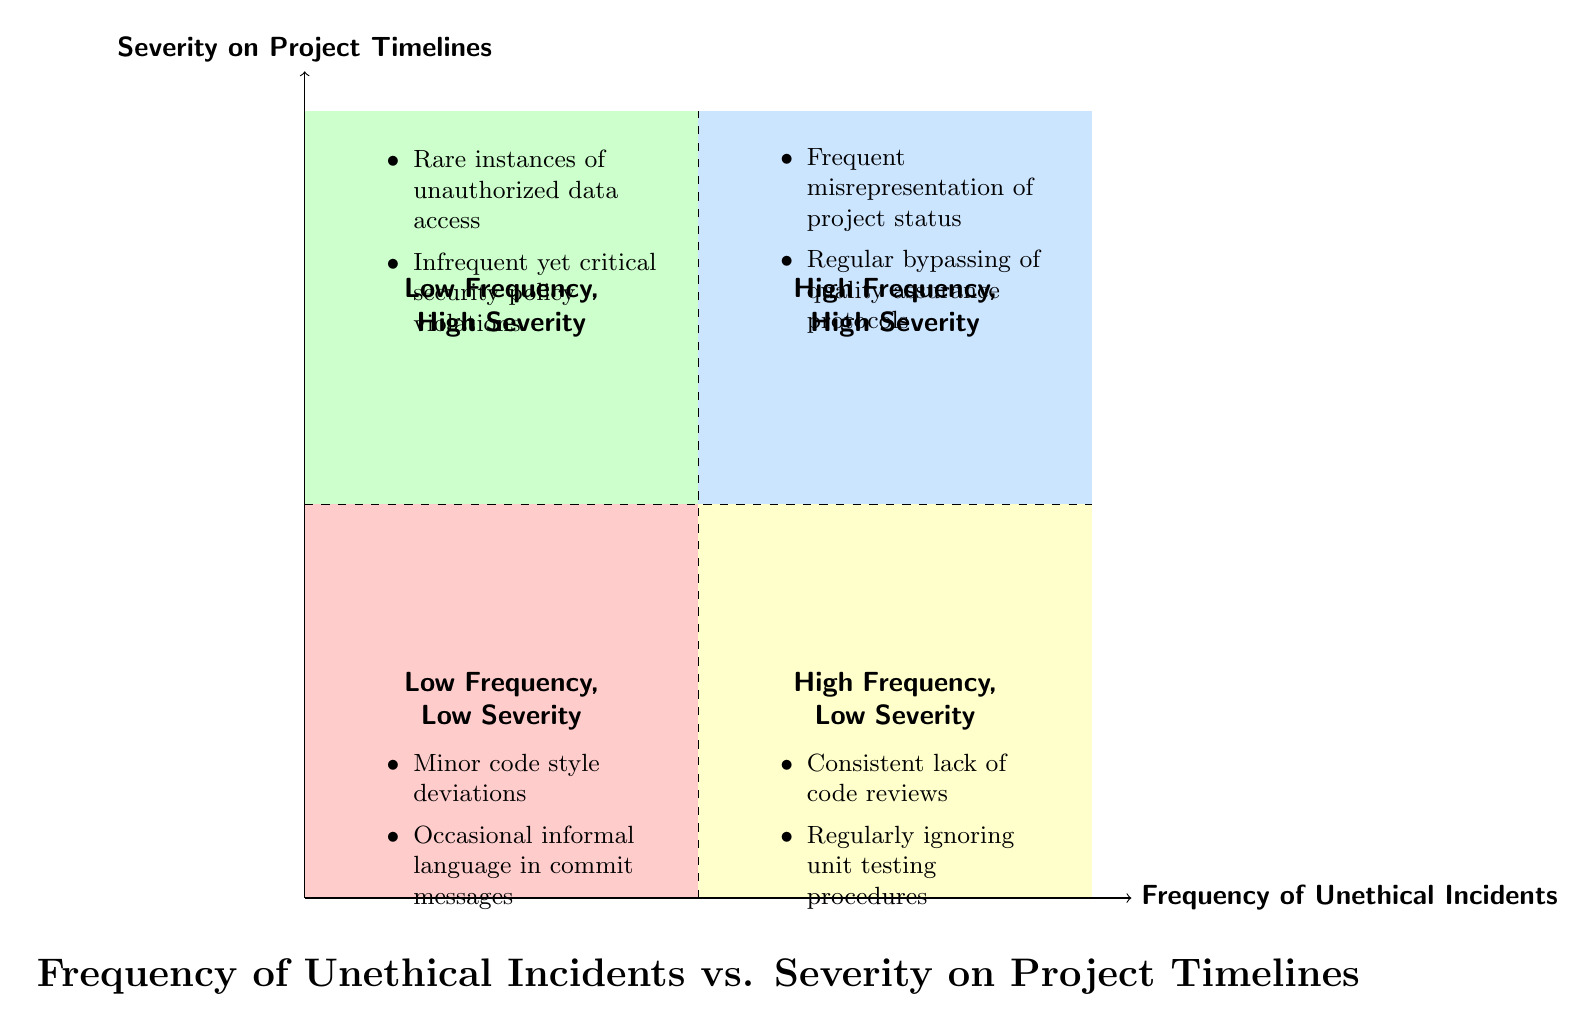What are the two labels for high frequency, high severity quadrant? The high frequency, high severity quadrant is labeled as "High Frequency, High Severity." The examples listed include "Frequent misrepresentation of project status" and "Regular bypassing of quality assurance protocols."
Answer: High Frequency, High Severity How many examples are listed in the low frequency, low severity quadrant? In the low frequency, low severity quadrant, there are two examples: "Minor code style deviations" and "Occasional informal language in commit messages." Therefore, the total count is 2.
Answer: 2 Which quadrant contains instances of unauthorized data access? Unauthorized data access is mentioned in the low frequency, high severity quadrant; thus, it is categorized there since it describes a rare but significant incident.
Answer: Low Frequency, High Severity What is the label of the quadrant with high frequency and low severity? The label for the quadrant with high frequency and low severity is "High Frequency, Low Severity," indicating that incidents here occur often but have less significant impact.
Answer: High Frequency, Low Severity Which type of incidents is represented in both high frequency and high severity? The quadrant for high frequency and high severity includes examples like "Frequent misrepresentation of project status" and "Regular bypassing of quality assurance protocols." This indicates the incidents pose serious risks while occurring frequently.
Answer: Frequent misrepresentation of project status, Regular bypassing of quality assurance protocols What kind of practices fall under the low frequency, high severity quadrant? The low frequency, high severity quadrant is characterized by significant incidents that occur rarely, such as "Rare instances of unauthorized data access" and "Infrequent yet critical security policy violations." This suggests that although these incidents are not common, they are critical when they do occur.
Answer: Rare instances of unauthorized data access, Infrequent yet critical security policy violations What is the primary characteristic of the high frequency, low severity incidents? Incidents categorized under high frequency and low severity typically exhibit a pattern of occurrence without serious implications, such as "Consistent lack of code reviews" and "Regularly ignoring unit testing procedures," indicating behavioral issues that need addressing but do not immediately threaten project integrity.
Answer: Consistent lack of code reviews, Regularly ignoring unit testing procedures Which quadrant experiences minor code style deviations? Minor code style deviations are classified under the low frequency, low severity quadrant, suggesting that these issues arise infrequently and have a minimal impact on the project.
Answer: Low Frequency, Low Severity 